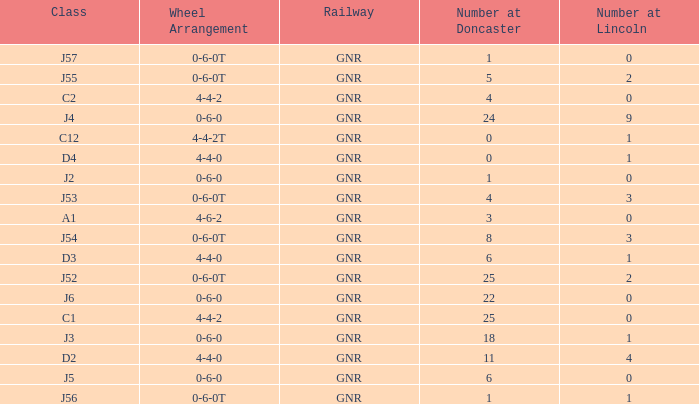Which Class has a Number at Lincoln smaller than 1 and a Wheel Arrangement of 0-6-0? J2, J5, J6. 